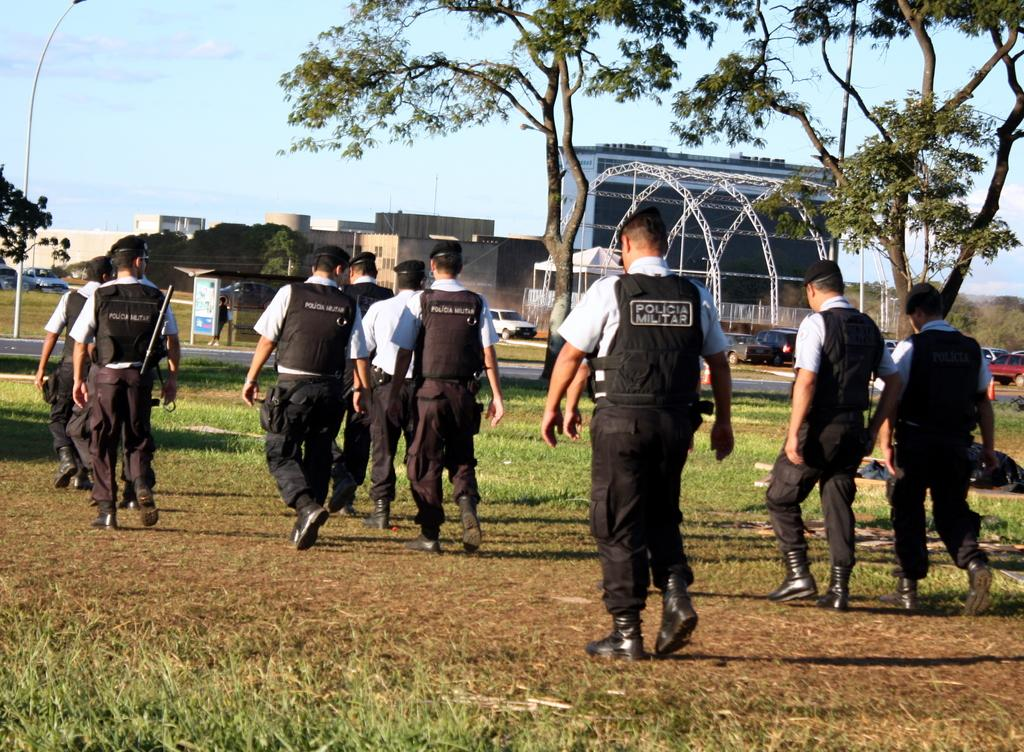How many people are in the image? There is a group of people in the image, but the exact number is not specified. What is the position of the people in the image? The people are on the ground in the image. What can be seen in the background of the image? There are buildings, trees, vehicles, and the sky visible in the background of the image. What type of lamp is being used by the people in the image? There is no lamp present in the image; the people are on the ground without any visible lamps. 